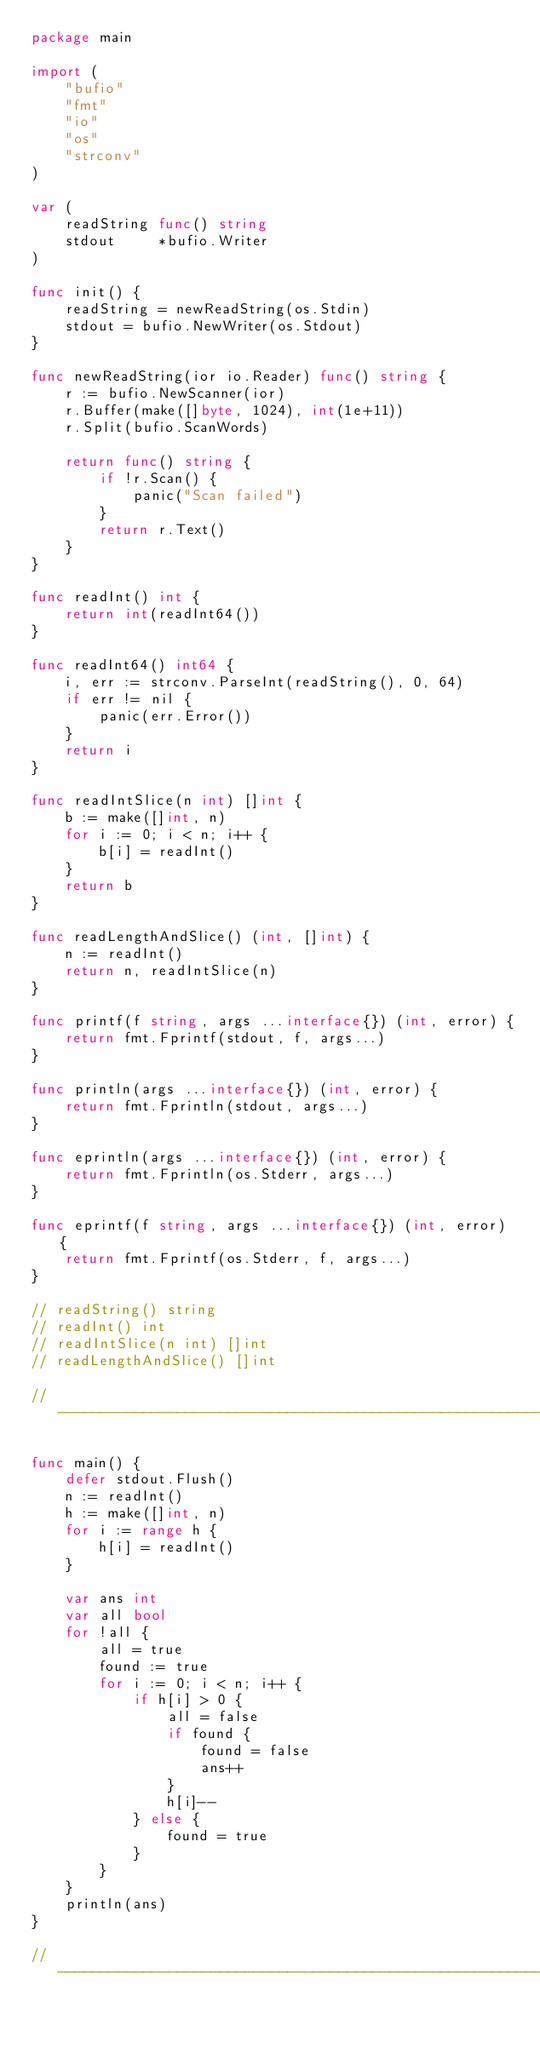<code> <loc_0><loc_0><loc_500><loc_500><_Go_>package main

import (
	"bufio"
	"fmt"
	"io"
	"os"
	"strconv"
)

var (
	readString func() string
	stdout     *bufio.Writer
)

func init() {
	readString = newReadString(os.Stdin)
	stdout = bufio.NewWriter(os.Stdout)
}

func newReadString(ior io.Reader) func() string {
	r := bufio.NewScanner(ior)
	r.Buffer(make([]byte, 1024), int(1e+11))
	r.Split(bufio.ScanWords)

	return func() string {
		if !r.Scan() {
			panic("Scan failed")
		}
		return r.Text()
	}
}

func readInt() int {
	return int(readInt64())
}

func readInt64() int64 {
	i, err := strconv.ParseInt(readString(), 0, 64)
	if err != nil {
		panic(err.Error())
	}
	return i
}

func readIntSlice(n int) []int {
	b := make([]int, n)
	for i := 0; i < n; i++ {
		b[i] = readInt()
	}
	return b
}

func readLengthAndSlice() (int, []int) {
	n := readInt()
	return n, readIntSlice(n)
}

func printf(f string, args ...interface{}) (int, error) {
	return fmt.Fprintf(stdout, f, args...)
}

func println(args ...interface{}) (int, error) {
	return fmt.Fprintln(stdout, args...)
}

func eprintln(args ...interface{}) (int, error) {
	return fmt.Fprintln(os.Stderr, args...)
}

func eprintf(f string, args ...interface{}) (int, error) {
	return fmt.Fprintf(os.Stderr, f, args...)
}

// readString() string
// readInt() int
// readIntSlice(n int) []int
// readLengthAndSlice() []int

// -----------------------------------------------------------------------------

func main() {
	defer stdout.Flush()
	n := readInt()
	h := make([]int, n)
	for i := range h {
		h[i] = readInt()
	}

	var ans int
	var all bool
	for !all {
		all = true
		found := true
		for i := 0; i < n; i++ {
			if h[i] > 0 {
				all = false
				if found {
					found = false
					ans++
				}
				h[i]--
			} else {
				found = true
			}
		}
	}
	println(ans)
}

// -----------------------------------------------------------------------------
</code> 